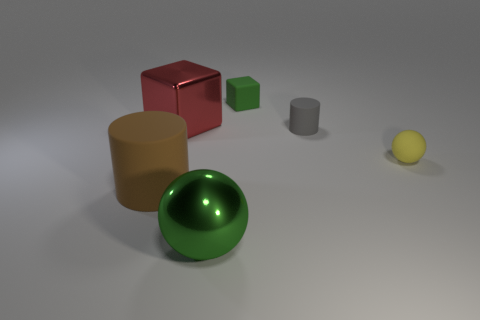There is a tiny thing that is the same color as the big metal sphere; what is its material?
Your answer should be compact. Rubber. Is there a block that has the same material as the small ball?
Make the answer very short. Yes. There is a cylinder that is the same size as the red metallic block; what is it made of?
Make the answer very short. Rubber. There is a ball in front of the matte cylinder that is left of the tiny object behind the red metallic cube; what is its size?
Give a very brief answer. Large. There is a big thing that is behind the matte ball; are there any big red metal objects in front of it?
Your answer should be very brief. No. Do the tiny yellow thing and the green thing in front of the red shiny object have the same shape?
Your response must be concise. Yes. What is the color of the metal object that is behind the large ball?
Give a very brief answer. Red. There is a green thing that is in front of the tiny thing behind the metallic cube; how big is it?
Offer a terse response. Large. Is the shape of the matte thing left of the tiny matte block the same as  the red object?
Provide a short and direct response. No. What material is the gray thing that is the same shape as the big brown rubber thing?
Give a very brief answer. Rubber. 